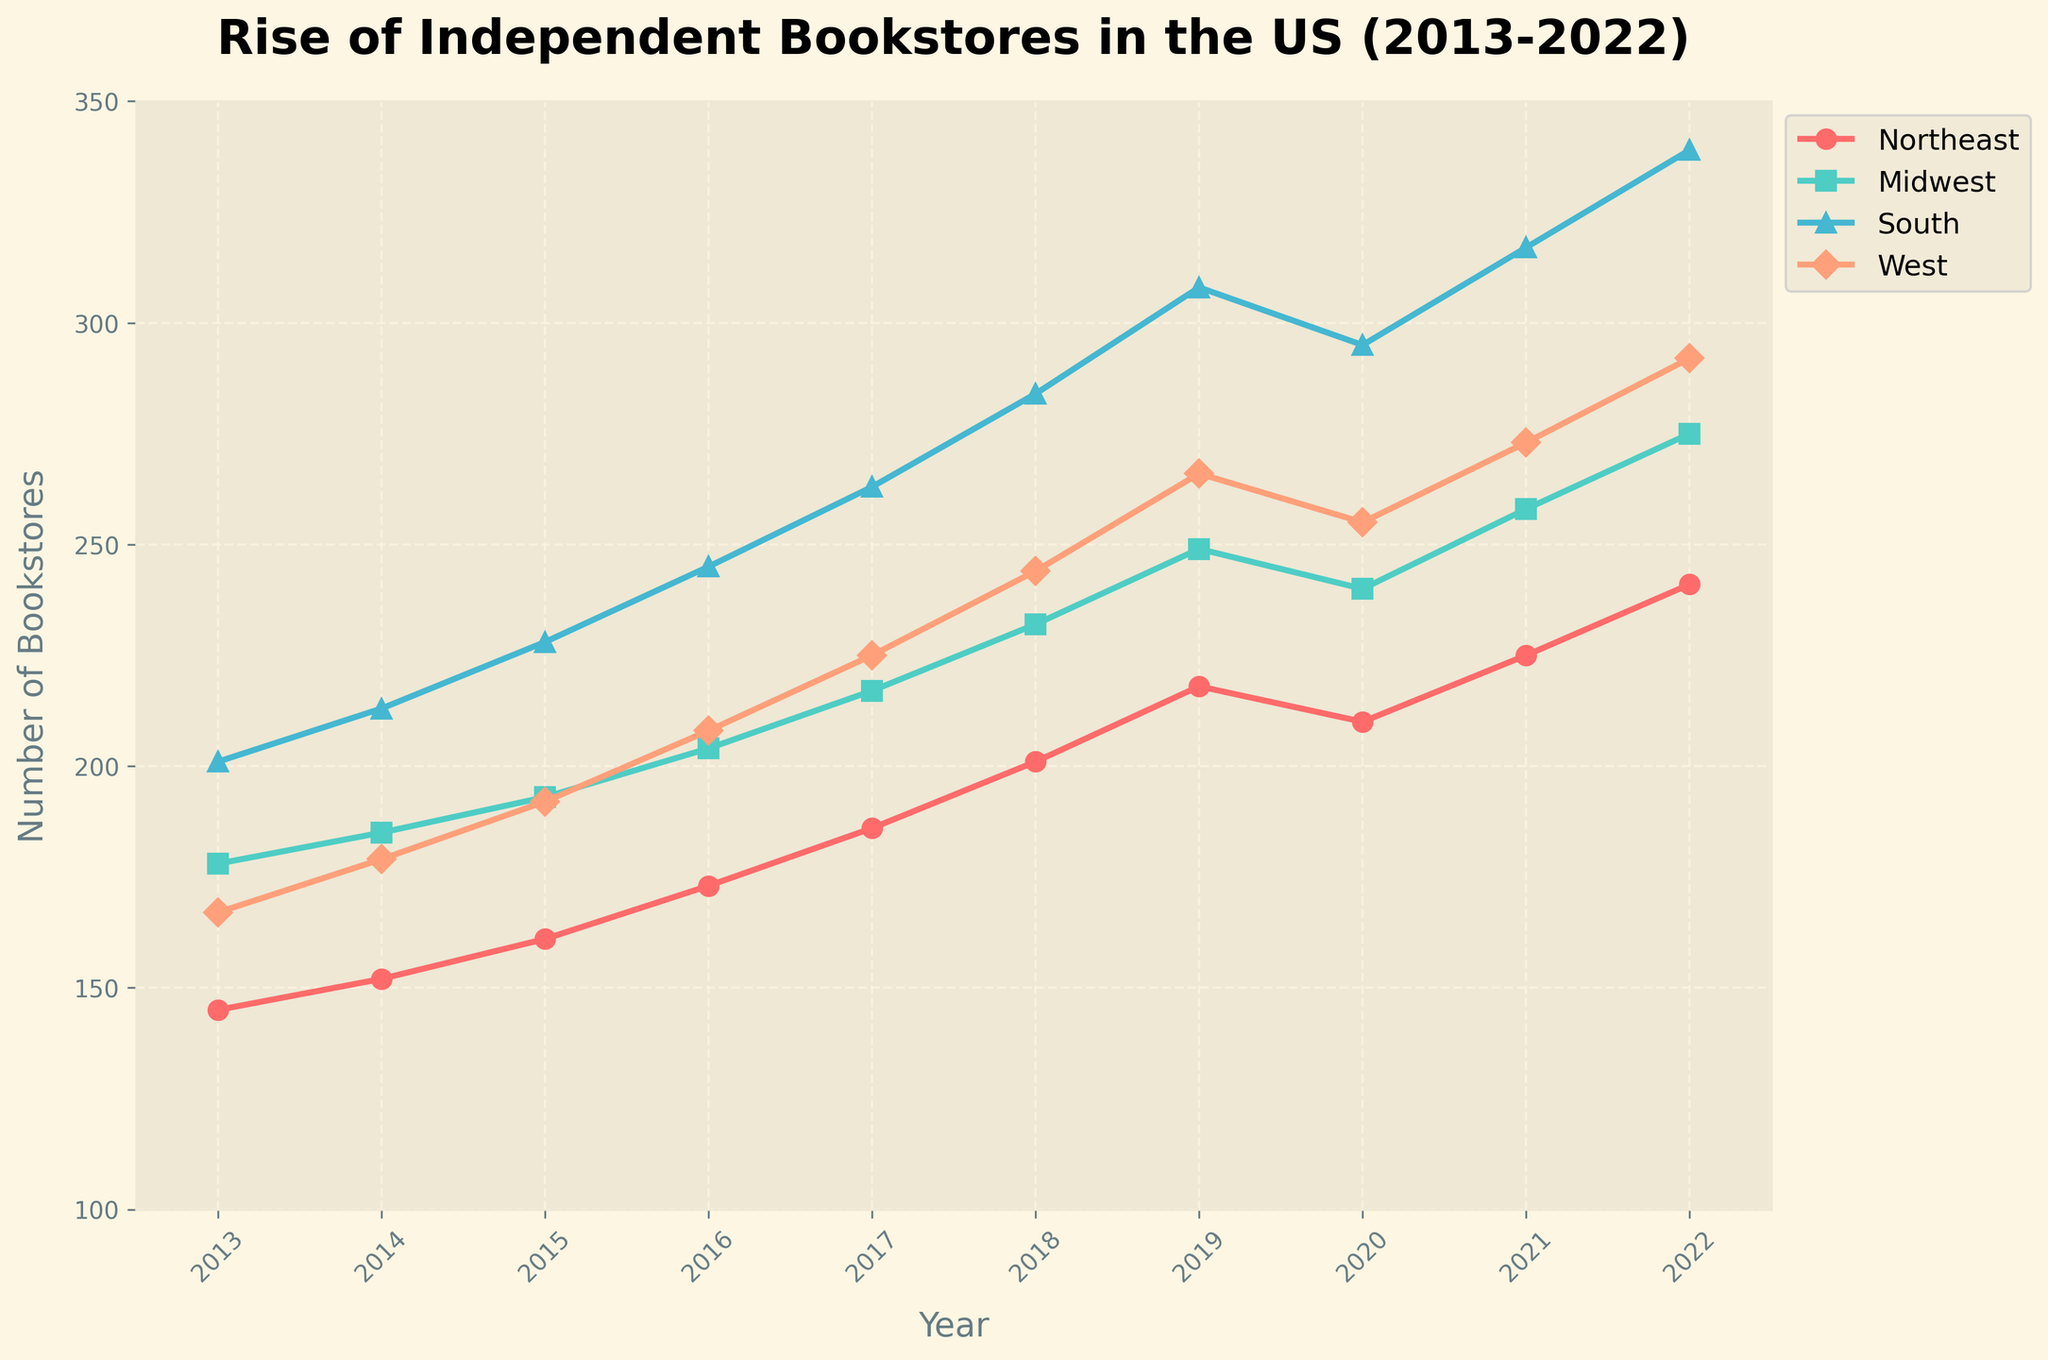Which region had the highest number of independent bookstores in 2022? By observing the lines on the chart, we see that the ‘South’ region has the highest endpoint in 2022, indicating the highest number of independent bookstores.
Answer: South How did the number of bookstores in the 'Midwest' region change from 2013 to 2016? Look at the values on the chart for the ‘Midwest’ region in 2013 and 2016. The number increased from 178 to 204. The change is calculated by subtracting the 2013 value from the 2016 value: 204 - 178 = 26.
Answer: Increased by 26 Which region showed the most consistent increase in bookstores over the given period? By observing the overall trend lines across all regions, the 'South' region shows a consistently increasing trend from 2013 to 2022 without any year of decline.
Answer: South What was the total number of bookstores across all regions in 2019? Sum up the number of bookstores in all regions for the year 2019: Northeast (218) + Midwest (249) + South (308) + West (266). Total = 218 + 249 + 308 + 266 = 1041.
Answer: 1041 Between which years did the 'West' region see the largest increase in bookstores? Compare the differences in the number of bookstores year by year for the 'West' region: 2014 (12), 2015 (13), 2016 (16), 2017 (17), 2018 (19), 2019 (22), 2020 (-11), 2021 (18), 2022 (19). The largest increase is between 2018 and 2019 (22).
Answer: 2018 and 2019 What is the average number of bookstores in the 'Northeast' region over the decade? Add the values for the 'Northeast' region for each year and divide by the number of years: (145 + 152 + 161 + 173 + 186 + 201 + 218 + 210 + 225 + 241) / 10 = 1912 / 10 = 191.2.
Answer: 191.2 Which region had the least increase in bookstores from 2013 to 2022? Calculate the differences between 2022 and 2013 values for all regions: Northeast (241-145 = 96), Midwest (275-178 = 97), South (339-201 = 138), West (292-167 = 125). The least increase is in the 'Northeast' region (96).
Answer: Northeast In what year did the 'South' region surpass 300 bookstores? Refer to the chart and identify the first year the 'South' region line crosses the 300 mark. This occurs between 2018 (284) and 2019 (308). Thus, 2019 is the year.
Answer: 2019 